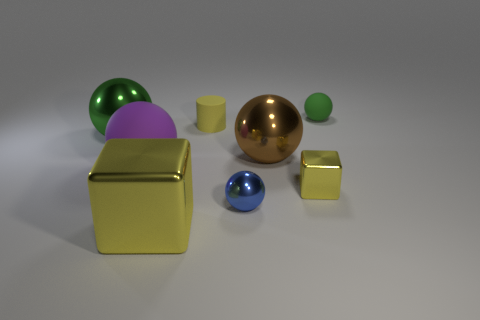Subtract all blue balls. How many balls are left? 4 Subtract all large brown metallic spheres. How many spheres are left? 4 Subtract all gray balls. Subtract all brown cylinders. How many balls are left? 5 Add 1 brown shiny spheres. How many objects exist? 9 Subtract all cylinders. How many objects are left? 7 Subtract all brown metallic things. Subtract all tiny rubber cylinders. How many objects are left? 6 Add 5 shiny objects. How many shiny objects are left? 10 Add 2 green metal balls. How many green metal balls exist? 3 Subtract 0 gray blocks. How many objects are left? 8 